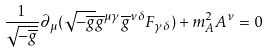<formula> <loc_0><loc_0><loc_500><loc_500>\frac { 1 } { \sqrt { - \overline { g } } } \partial _ { \mu } ( \sqrt { - \overline { g } } \overline { g } ^ { \mu \gamma } \overline { g } ^ { \nu \delta } F _ { \gamma \delta } ) + m _ { A } ^ { 2 } A ^ { \nu } = 0</formula> 